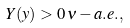<formula> <loc_0><loc_0><loc_500><loc_500>Y ( y ) > 0 \, \nu - a . e . ,</formula> 